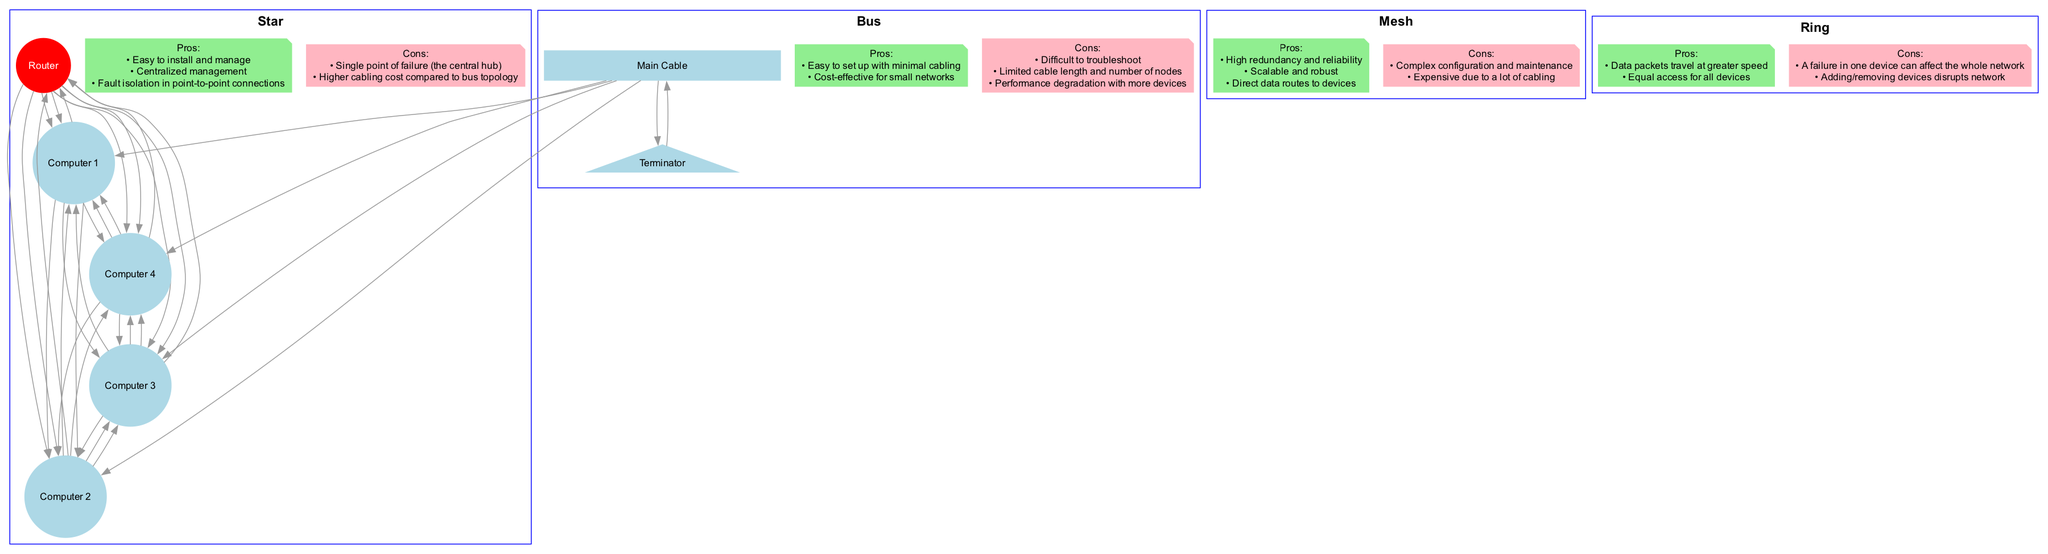What topology uses a central device? The diagram states that the Star topology has a Router at the center that connects to all other devices directly. This central device is essential for managing connections in the Star topology.
Answer: Star How many total nodes are in the Mesh topology? By counting the Router and the four Computers listed in the Mesh topology section of the diagram, we find there are five nodes in total (Router, Computer 1, Computer 2, Computer 3, Computer 4).
Answer: 5 Which topology allows for easy troubleshooting? In the diagram, the Star topology is noted for its easy installation and management, which includes simplified troubleshooting compared to the other topologies.
Answer: Star What is a disadvantage of the Ring topology? According to the diagram, one key disadvantage of the Ring topology is that a failure in one device can affect the entire network, highlighting its vulnerability to single points of failure.
Answer: A failure in one device can affect the whole network Which topology provides the highest redundancy? The Mesh topology is highlighted for its high redundancy and reliability. The diagram emphasizes that each device can connect to multiple others, ensuring communication if one link fails.
Answer: Mesh How many connections does Computer 1 have in the Bus topology? In the Bus topology section, the diagram shows that Computer 1 is connected to the Main Cable only, leading to the conclusion that it has just one connection in this configuration.
Answer: 1 Which topology's diagram utilizes a terminator? The Bus topology is the only one listed in the diagram that specifies the use of a Terminator, which is necessary to complete the circuit of the main cable.
Answer: Bus What is a benefit of the Star topology's centralized management? The diagram indicates that centralized management in the Star topology allows easier control and monitoring of all network devices through the central Router, enhancing network organization and operations.
Answer: Centralized management Which topology includes direct data routes to devices? The Mesh topology facilitates direct communication paths between all devices. The diagram emphasizes that multiple direct connections enhance efficiency and reliability in data transmission.
Answer: Mesh What is the shape of nodes in the Ring topology? The diagram shows nodes in the Ring topology shaped as circles, representing the devices in this configuration, which connect to each other in a closed loop.
Answer: Circle 